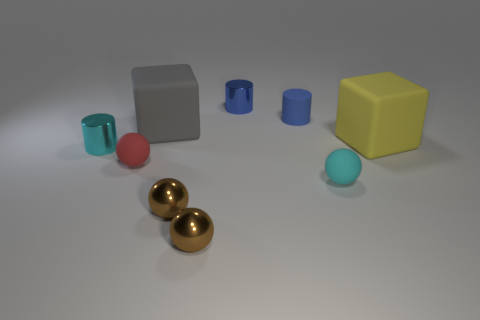Add 1 gray blocks. How many objects exist? 10 Subtract all cyan metal cylinders. How many cylinders are left? 2 Subtract 2 cylinders. How many cylinders are left? 1 Subtract all red balls. How many balls are left? 3 Subtract 0 red cubes. How many objects are left? 9 Subtract all cylinders. How many objects are left? 6 Subtract all purple cylinders. Subtract all yellow spheres. How many cylinders are left? 3 Subtract all red cylinders. How many gray cubes are left? 1 Subtract all brown metallic balls. Subtract all matte cylinders. How many objects are left? 6 Add 8 large yellow blocks. How many large yellow blocks are left? 9 